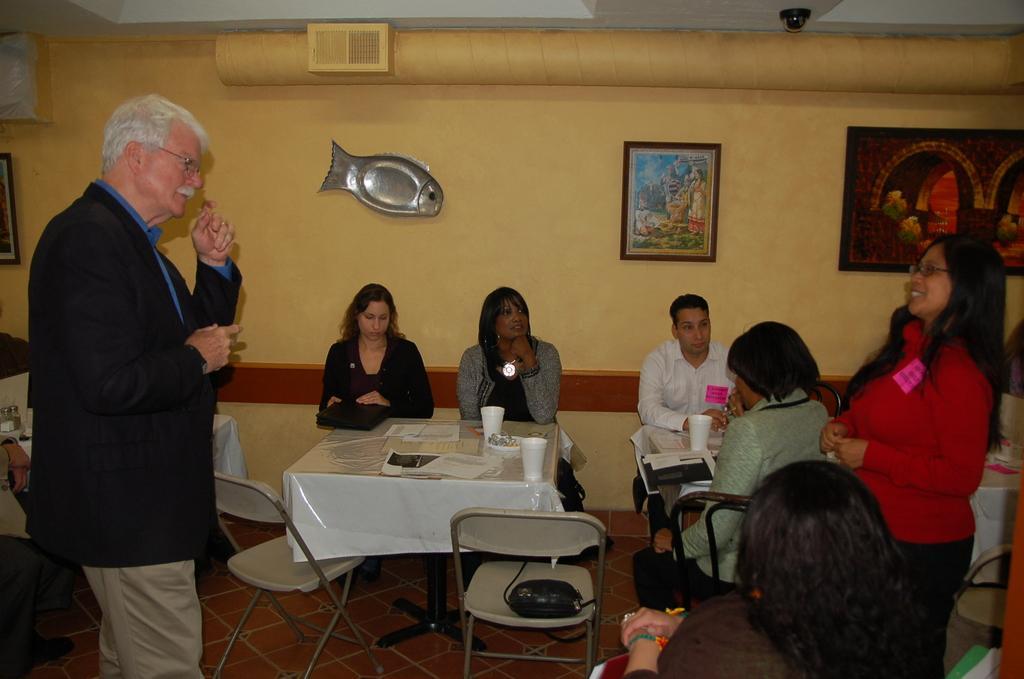Please provide a concise description of this image. This picture is clicked inside a room. There are people sitting on chairs at the table. On the table there papers and glasses. The man to the left corner and the woman to the standing and see inside the speaking to each other. On the wall there are picture frames hanging. In the background there is wall. 